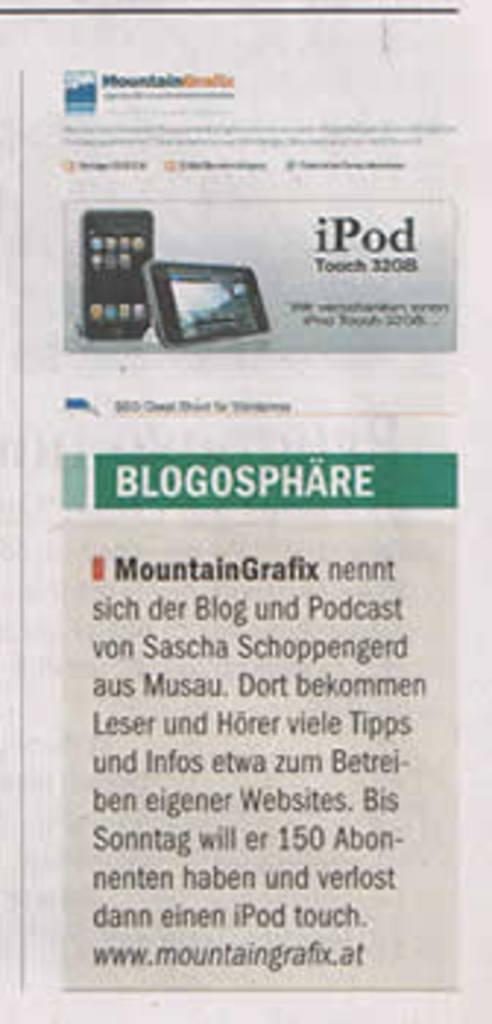<image>
Share a concise interpretation of the image provided. An advert for a ipod with the word blogosphare under it 